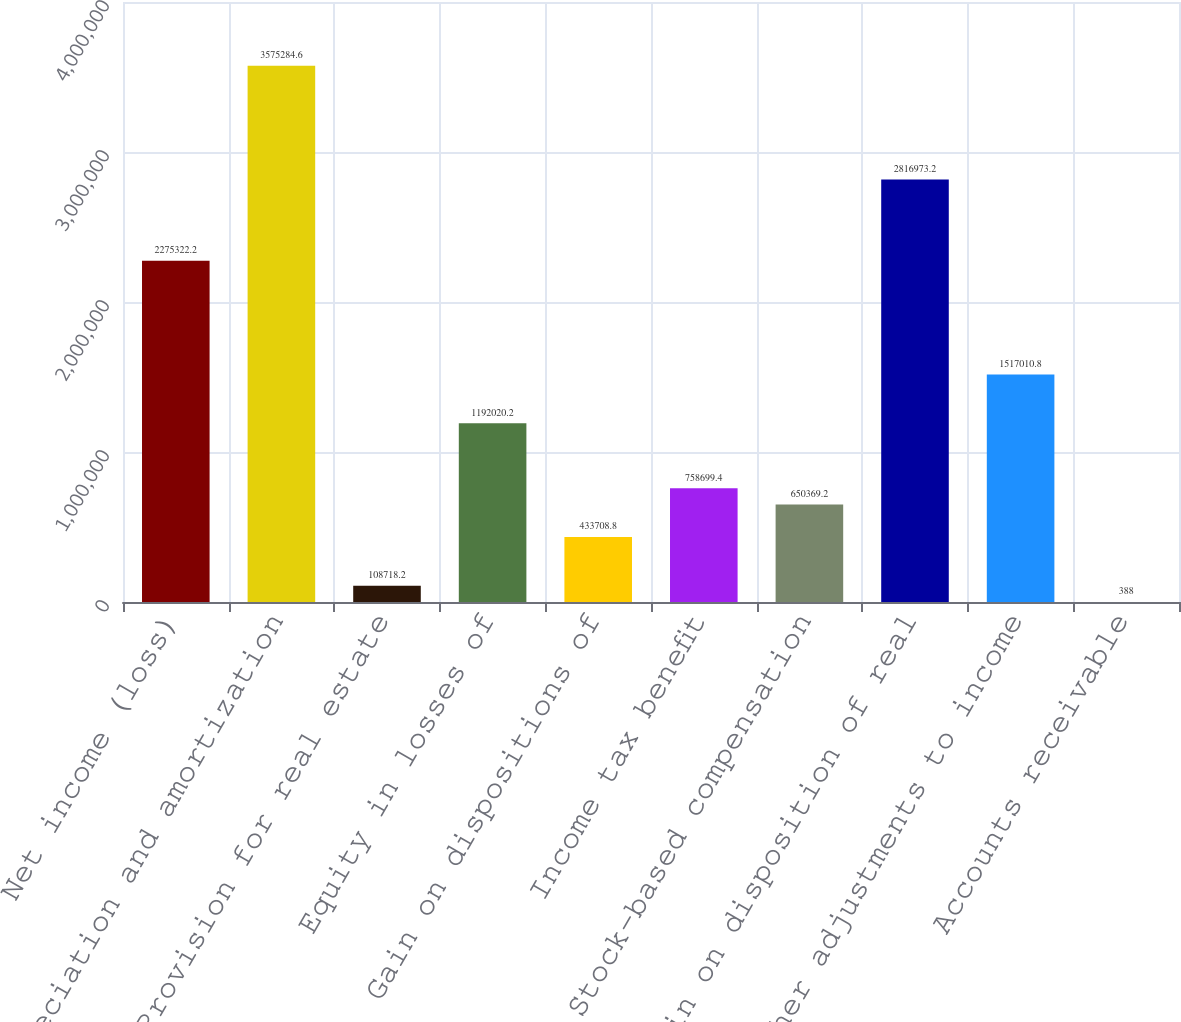<chart> <loc_0><loc_0><loc_500><loc_500><bar_chart><fcel>Net income (loss)<fcel>Depreciation and amortization<fcel>Provision for real estate<fcel>Equity in losses of<fcel>Gain on dispositions of<fcel>Income tax benefit<fcel>Stock-based compensation<fcel>Gain on disposition of real<fcel>Other adjustments to income<fcel>Accounts receivable<nl><fcel>2.27532e+06<fcel>3.57528e+06<fcel>108718<fcel>1.19202e+06<fcel>433709<fcel>758699<fcel>650369<fcel>2.81697e+06<fcel>1.51701e+06<fcel>388<nl></chart> 